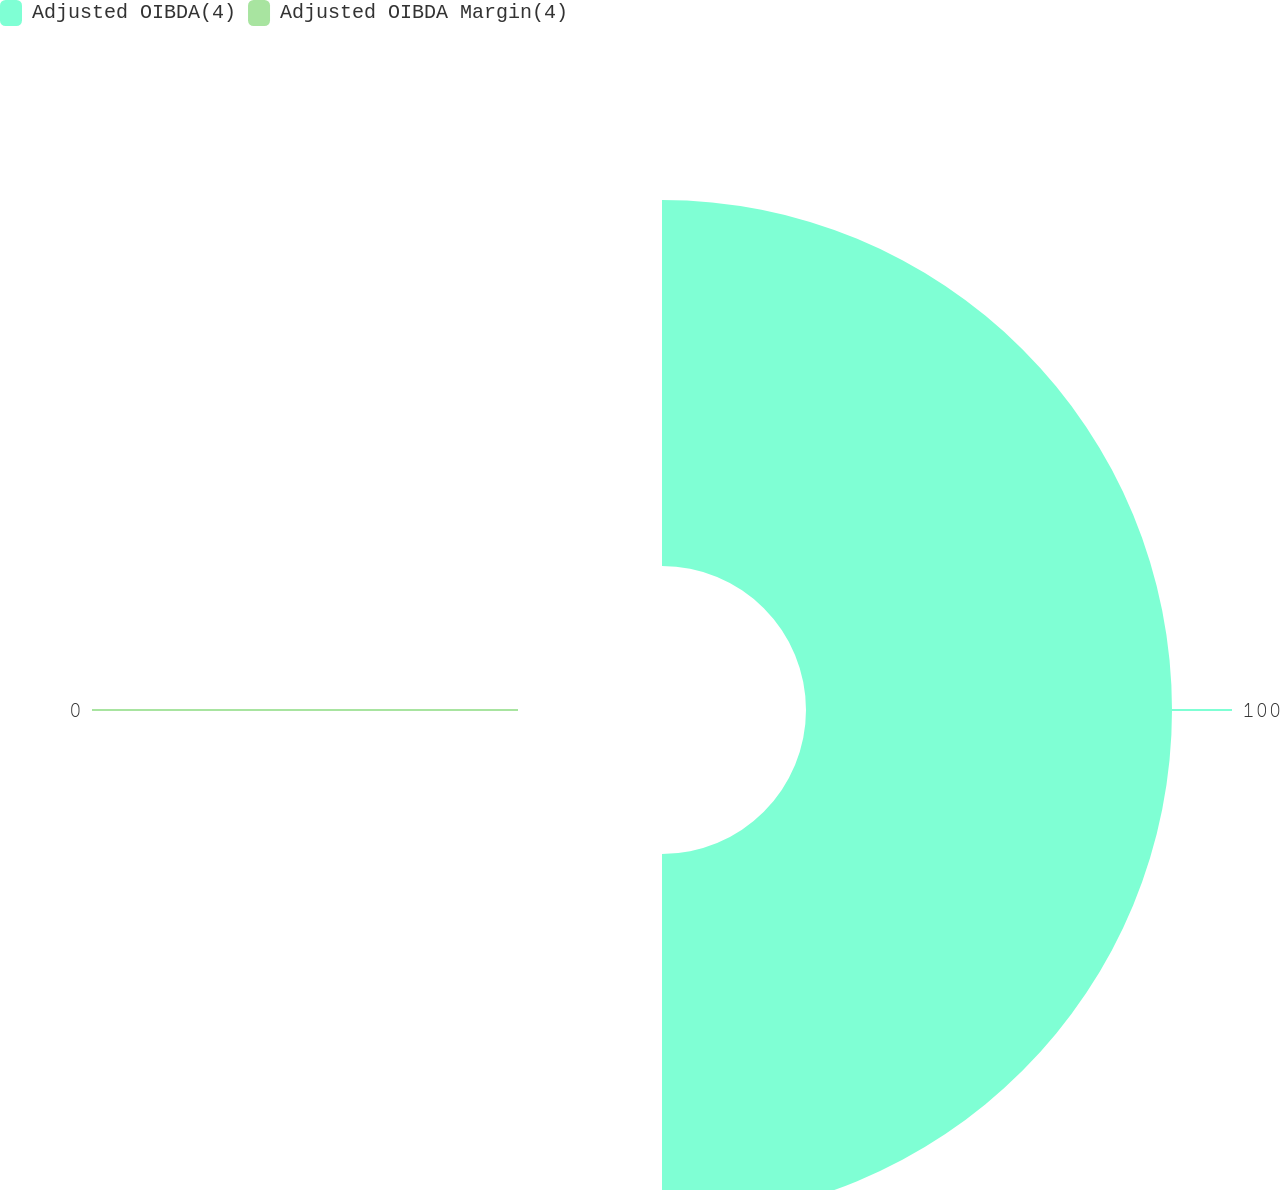Convert chart. <chart><loc_0><loc_0><loc_500><loc_500><pie_chart><fcel>Adjusted OIBDA(4)<fcel>Adjusted OIBDA Margin(4)<nl><fcel>100.0%<fcel>0.0%<nl></chart> 